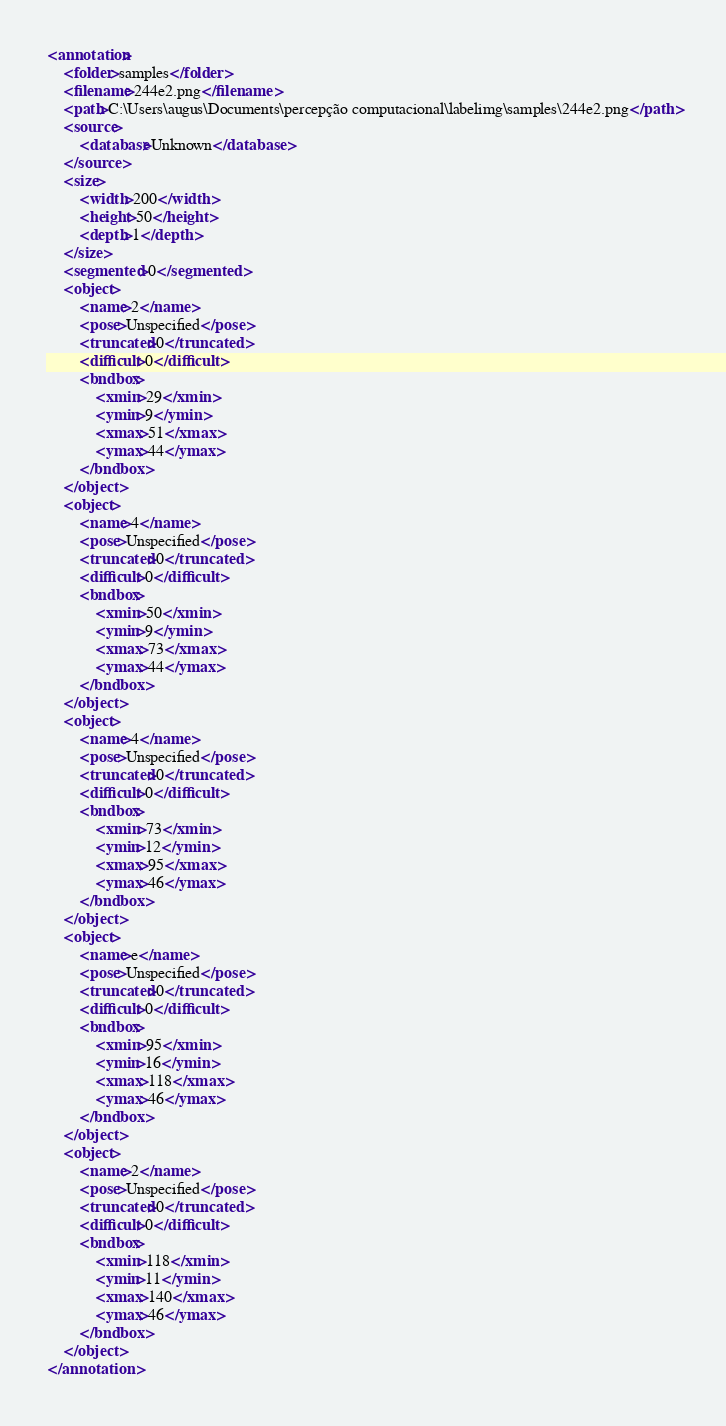<code> <loc_0><loc_0><loc_500><loc_500><_XML_><annotation>
	<folder>samples</folder>
	<filename>244e2.png</filename>
	<path>C:\Users\augus\Documents\percepção computacional\labelimg\samples\244e2.png</path>
	<source>
		<database>Unknown</database>
	</source>
	<size>
		<width>200</width>
		<height>50</height>
		<depth>1</depth>
	</size>
	<segmented>0</segmented>
	<object>
		<name>2</name>
		<pose>Unspecified</pose>
		<truncated>0</truncated>
		<difficult>0</difficult>
		<bndbox>
			<xmin>29</xmin>
			<ymin>9</ymin>
			<xmax>51</xmax>
			<ymax>44</ymax>
		</bndbox>
	</object>
	<object>
		<name>4</name>
		<pose>Unspecified</pose>
		<truncated>0</truncated>
		<difficult>0</difficult>
		<bndbox>
			<xmin>50</xmin>
			<ymin>9</ymin>
			<xmax>73</xmax>
			<ymax>44</ymax>
		</bndbox>
	</object>
	<object>
		<name>4</name>
		<pose>Unspecified</pose>
		<truncated>0</truncated>
		<difficult>0</difficult>
		<bndbox>
			<xmin>73</xmin>
			<ymin>12</ymin>
			<xmax>95</xmax>
			<ymax>46</ymax>
		</bndbox>
	</object>
	<object>
		<name>e</name>
		<pose>Unspecified</pose>
		<truncated>0</truncated>
		<difficult>0</difficult>
		<bndbox>
			<xmin>95</xmin>
			<ymin>16</ymin>
			<xmax>118</xmax>
			<ymax>46</ymax>
		</bndbox>
	</object>
	<object>
		<name>2</name>
		<pose>Unspecified</pose>
		<truncated>0</truncated>
		<difficult>0</difficult>
		<bndbox>
			<xmin>118</xmin>
			<ymin>11</ymin>
			<xmax>140</xmax>
			<ymax>46</ymax>
		</bndbox>
	</object>
</annotation>
</code> 